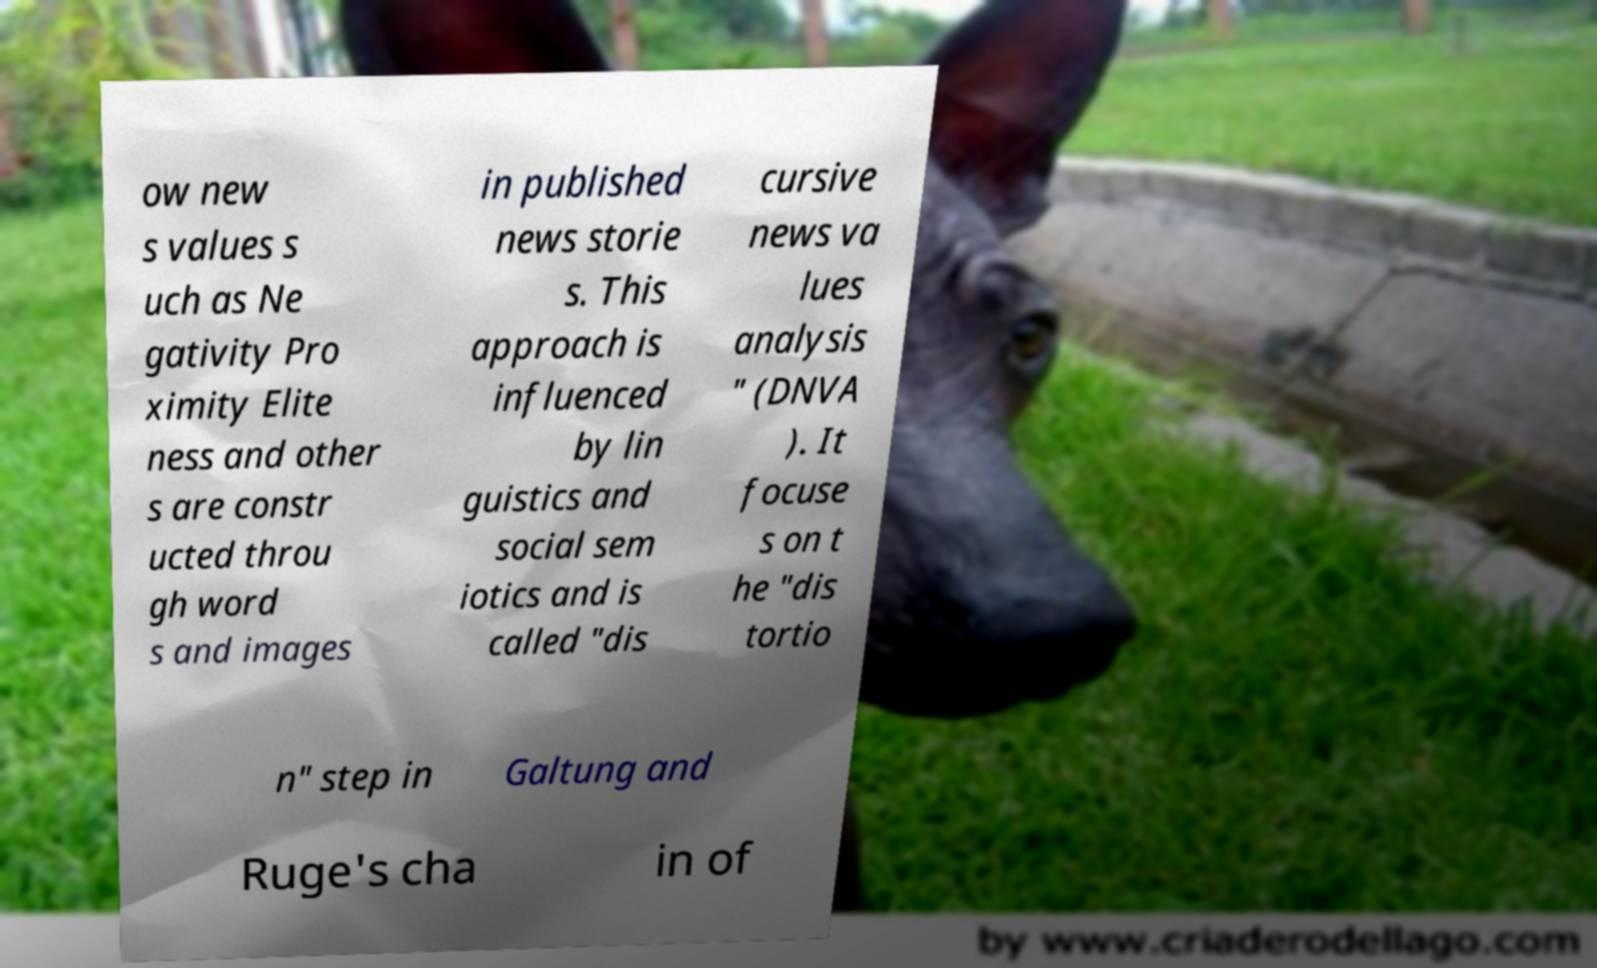For documentation purposes, I need the text within this image transcribed. Could you provide that? ow new s values s uch as Ne gativity Pro ximity Elite ness and other s are constr ucted throu gh word s and images in published news storie s. This approach is influenced by lin guistics and social sem iotics and is called "dis cursive news va lues analysis " (DNVA ). It focuse s on t he "dis tortio n" step in Galtung and Ruge's cha in of 